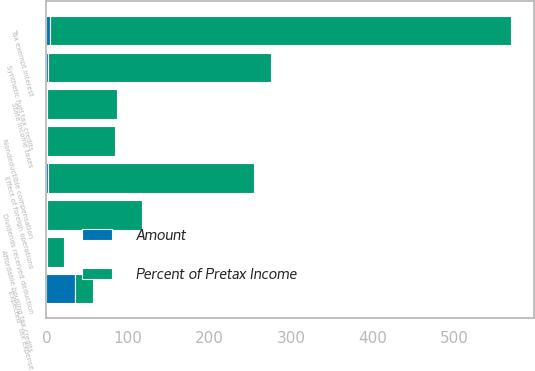Convert chart to OTSL. <chart><loc_0><loc_0><loc_500><loc_500><stacked_bar_chart><ecel><fcel>''Expected'' tax expense<fcel>Tax exempt interest<fcel>Dividends received deduction<fcel>State income taxes<fcel>Effect of foreign operations<fcel>Synthetic fuel tax credits<fcel>Affordable housing tax credits<fcel>Nondeductible compensation<nl><fcel>Percent of Pretax Income<fcel>22<fcel>566<fcel>117<fcel>86<fcel>253<fcel>274<fcel>22<fcel>83<nl><fcel>Amount<fcel>35<fcel>3.7<fcel>0.8<fcel>0.6<fcel>1.7<fcel>1.8<fcel>0.1<fcel>0.5<nl></chart> 